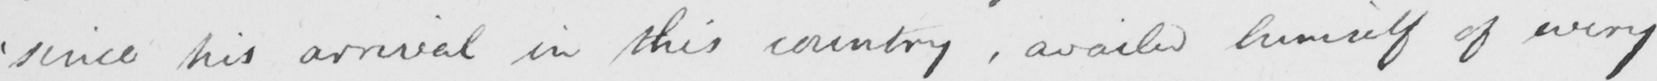Can you tell me what this handwritten text says? ' since his arrival in this country , availed himself of every 